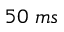Convert formula to latex. <formula><loc_0><loc_0><loc_500><loc_500>5 0 \, m s</formula> 